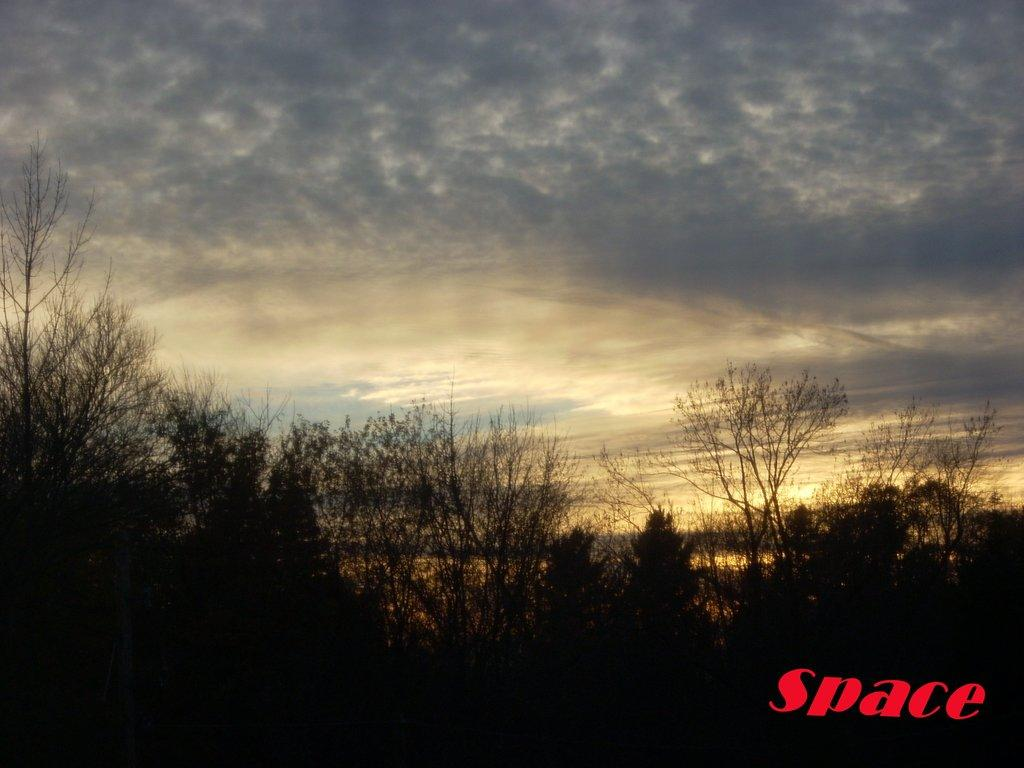What type of vegetation can be seen in the image? There are trees in the image. Where are the trees located in relation to the image? The trees are in the foreground of the image. What can be seen in the background of the image? There is sky visible in the background of the image. Is there any text present in the image? Yes, there is some text written at the bottom of the image. Are there any snails crawling on the trees in the image? There is no indication of snails or any other animals on the trees in the image. What type of sign can be seen in the image? There is no sign present in the image; it only features trees, sky, and text at the bottom. 